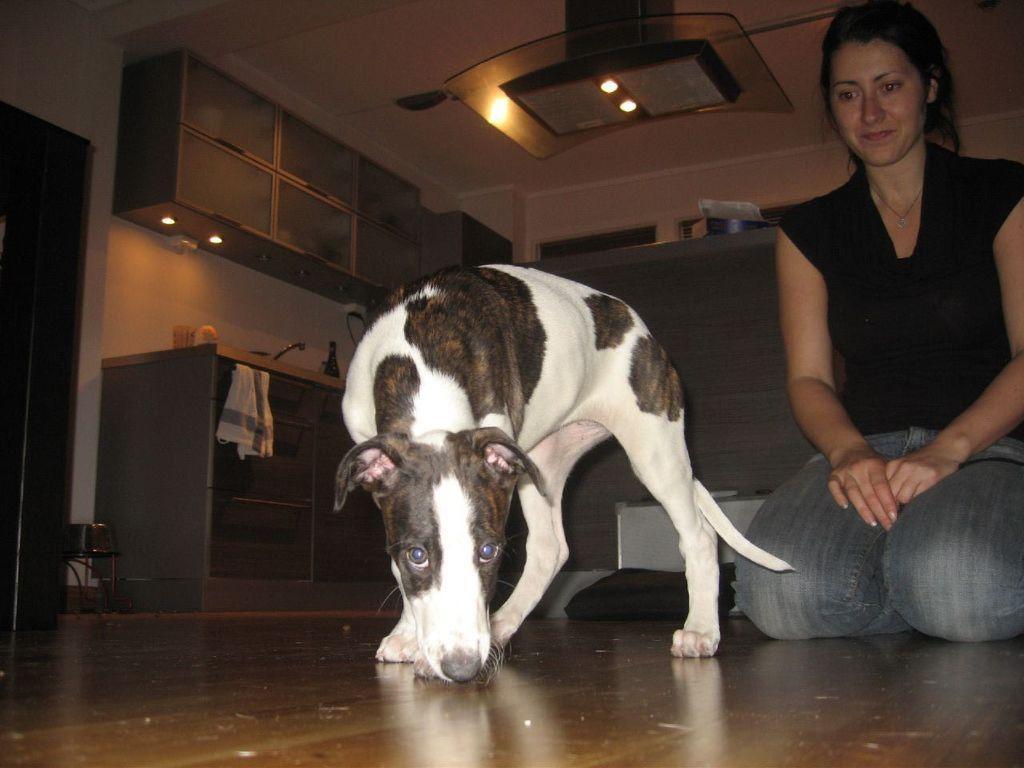Please provide a concise description of this image. In this image we can see a woman sitting on the floor, and she is smiling, and in front here is the dog, and here is the table and some objects on it, and here is the door, and at above here are the lights. 